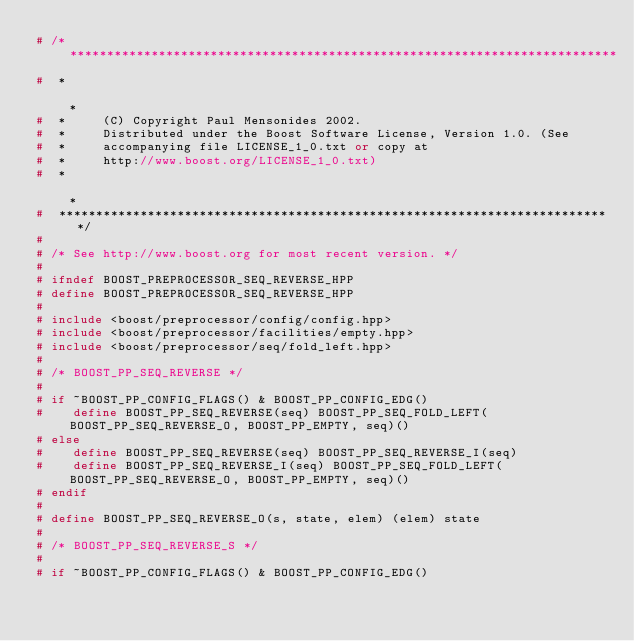<code> <loc_0><loc_0><loc_500><loc_500><_C++_># /* **************************************************************************
#  *                                                                          *
#  *     (C) Copyright Paul Mensonides 2002.
#  *     Distributed under the Boost Software License, Version 1.0. (See
#  *     accompanying file LICENSE_1_0.txt or copy at
#  *     http://www.boost.org/LICENSE_1_0.txt)
#  *                                                                          *
#  ************************************************************************** */
#
# /* See http://www.boost.org for most recent version. */
#
# ifndef BOOST_PREPROCESSOR_SEQ_REVERSE_HPP
# define BOOST_PREPROCESSOR_SEQ_REVERSE_HPP
#
# include <boost/preprocessor/config/config.hpp>
# include <boost/preprocessor/facilities/empty.hpp>
# include <boost/preprocessor/seq/fold_left.hpp>
#
# /* BOOST_PP_SEQ_REVERSE */
#
# if ~BOOST_PP_CONFIG_FLAGS() & BOOST_PP_CONFIG_EDG()
#    define BOOST_PP_SEQ_REVERSE(seq) BOOST_PP_SEQ_FOLD_LEFT(BOOST_PP_SEQ_REVERSE_O, BOOST_PP_EMPTY, seq)()
# else
#    define BOOST_PP_SEQ_REVERSE(seq) BOOST_PP_SEQ_REVERSE_I(seq)
#    define BOOST_PP_SEQ_REVERSE_I(seq) BOOST_PP_SEQ_FOLD_LEFT(BOOST_PP_SEQ_REVERSE_O, BOOST_PP_EMPTY, seq)()
# endif
#
# define BOOST_PP_SEQ_REVERSE_O(s, state, elem) (elem) state
#
# /* BOOST_PP_SEQ_REVERSE_S */
#
# if ~BOOST_PP_CONFIG_FLAGS() & BOOST_PP_CONFIG_EDG()</code> 